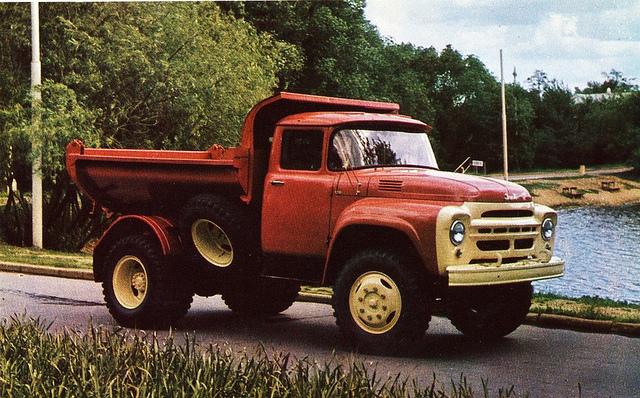What is the background of this photo?
Quick response, please. Lake. Is this a new truck?
Quick response, please. No. What color is the old truck?
Short answer required. Red. What color is the bumper?
Give a very brief answer. White. 